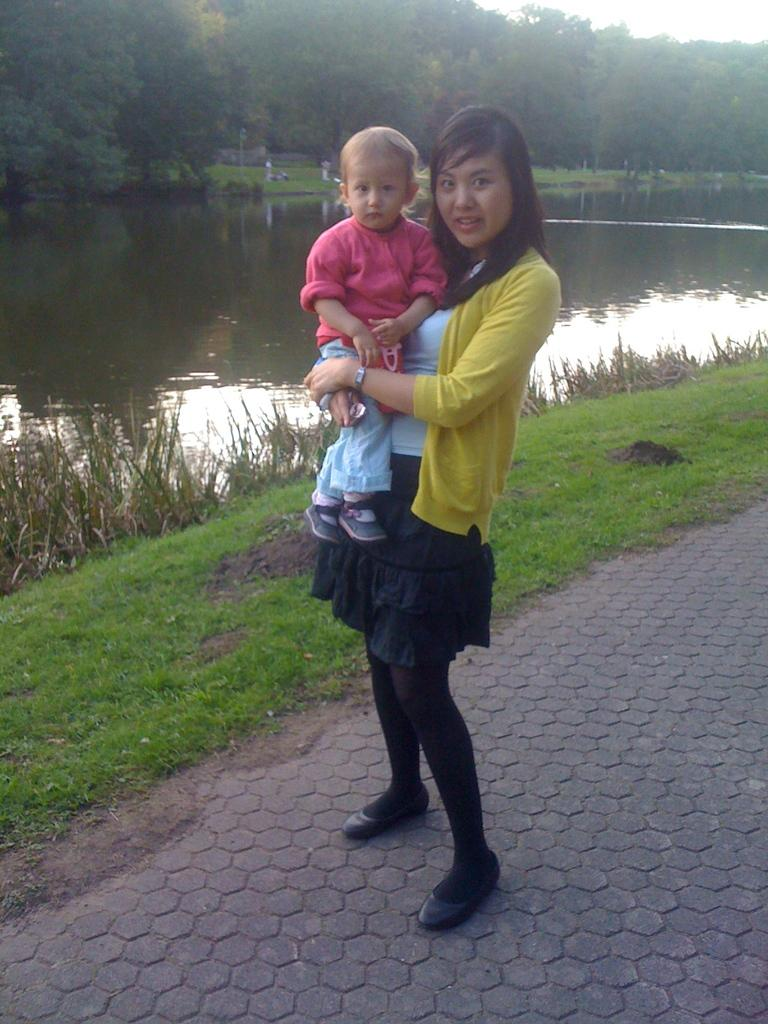Who is the main subject in the image? There is a woman in the image. What is the woman holding in the image? The woman is holding a baby. What type of environment is visible in the image? There is water, trees, grass, and the sky visible in the image. What can be seen in the background of the image? There are trees in the background of the image. What is the ground made of in the image? The ground is covered with grass in the image. What type of produce can be seen growing in the field in the image? There is no field present in the image, and therefore no produce can be seen growing. 